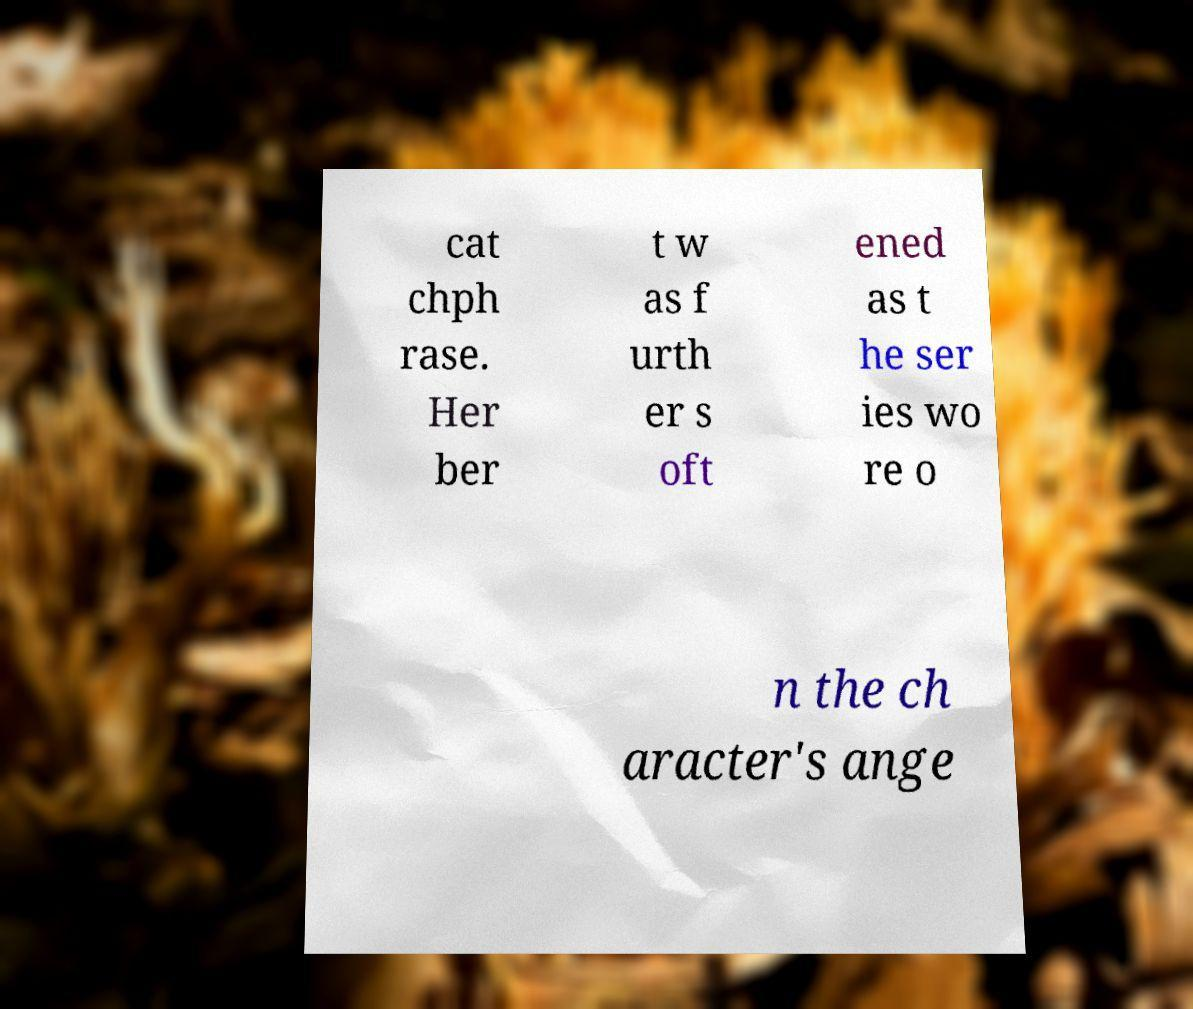I need the written content from this picture converted into text. Can you do that? cat chph rase. Her ber t w as f urth er s oft ened as t he ser ies wo re o n the ch aracter's ange 